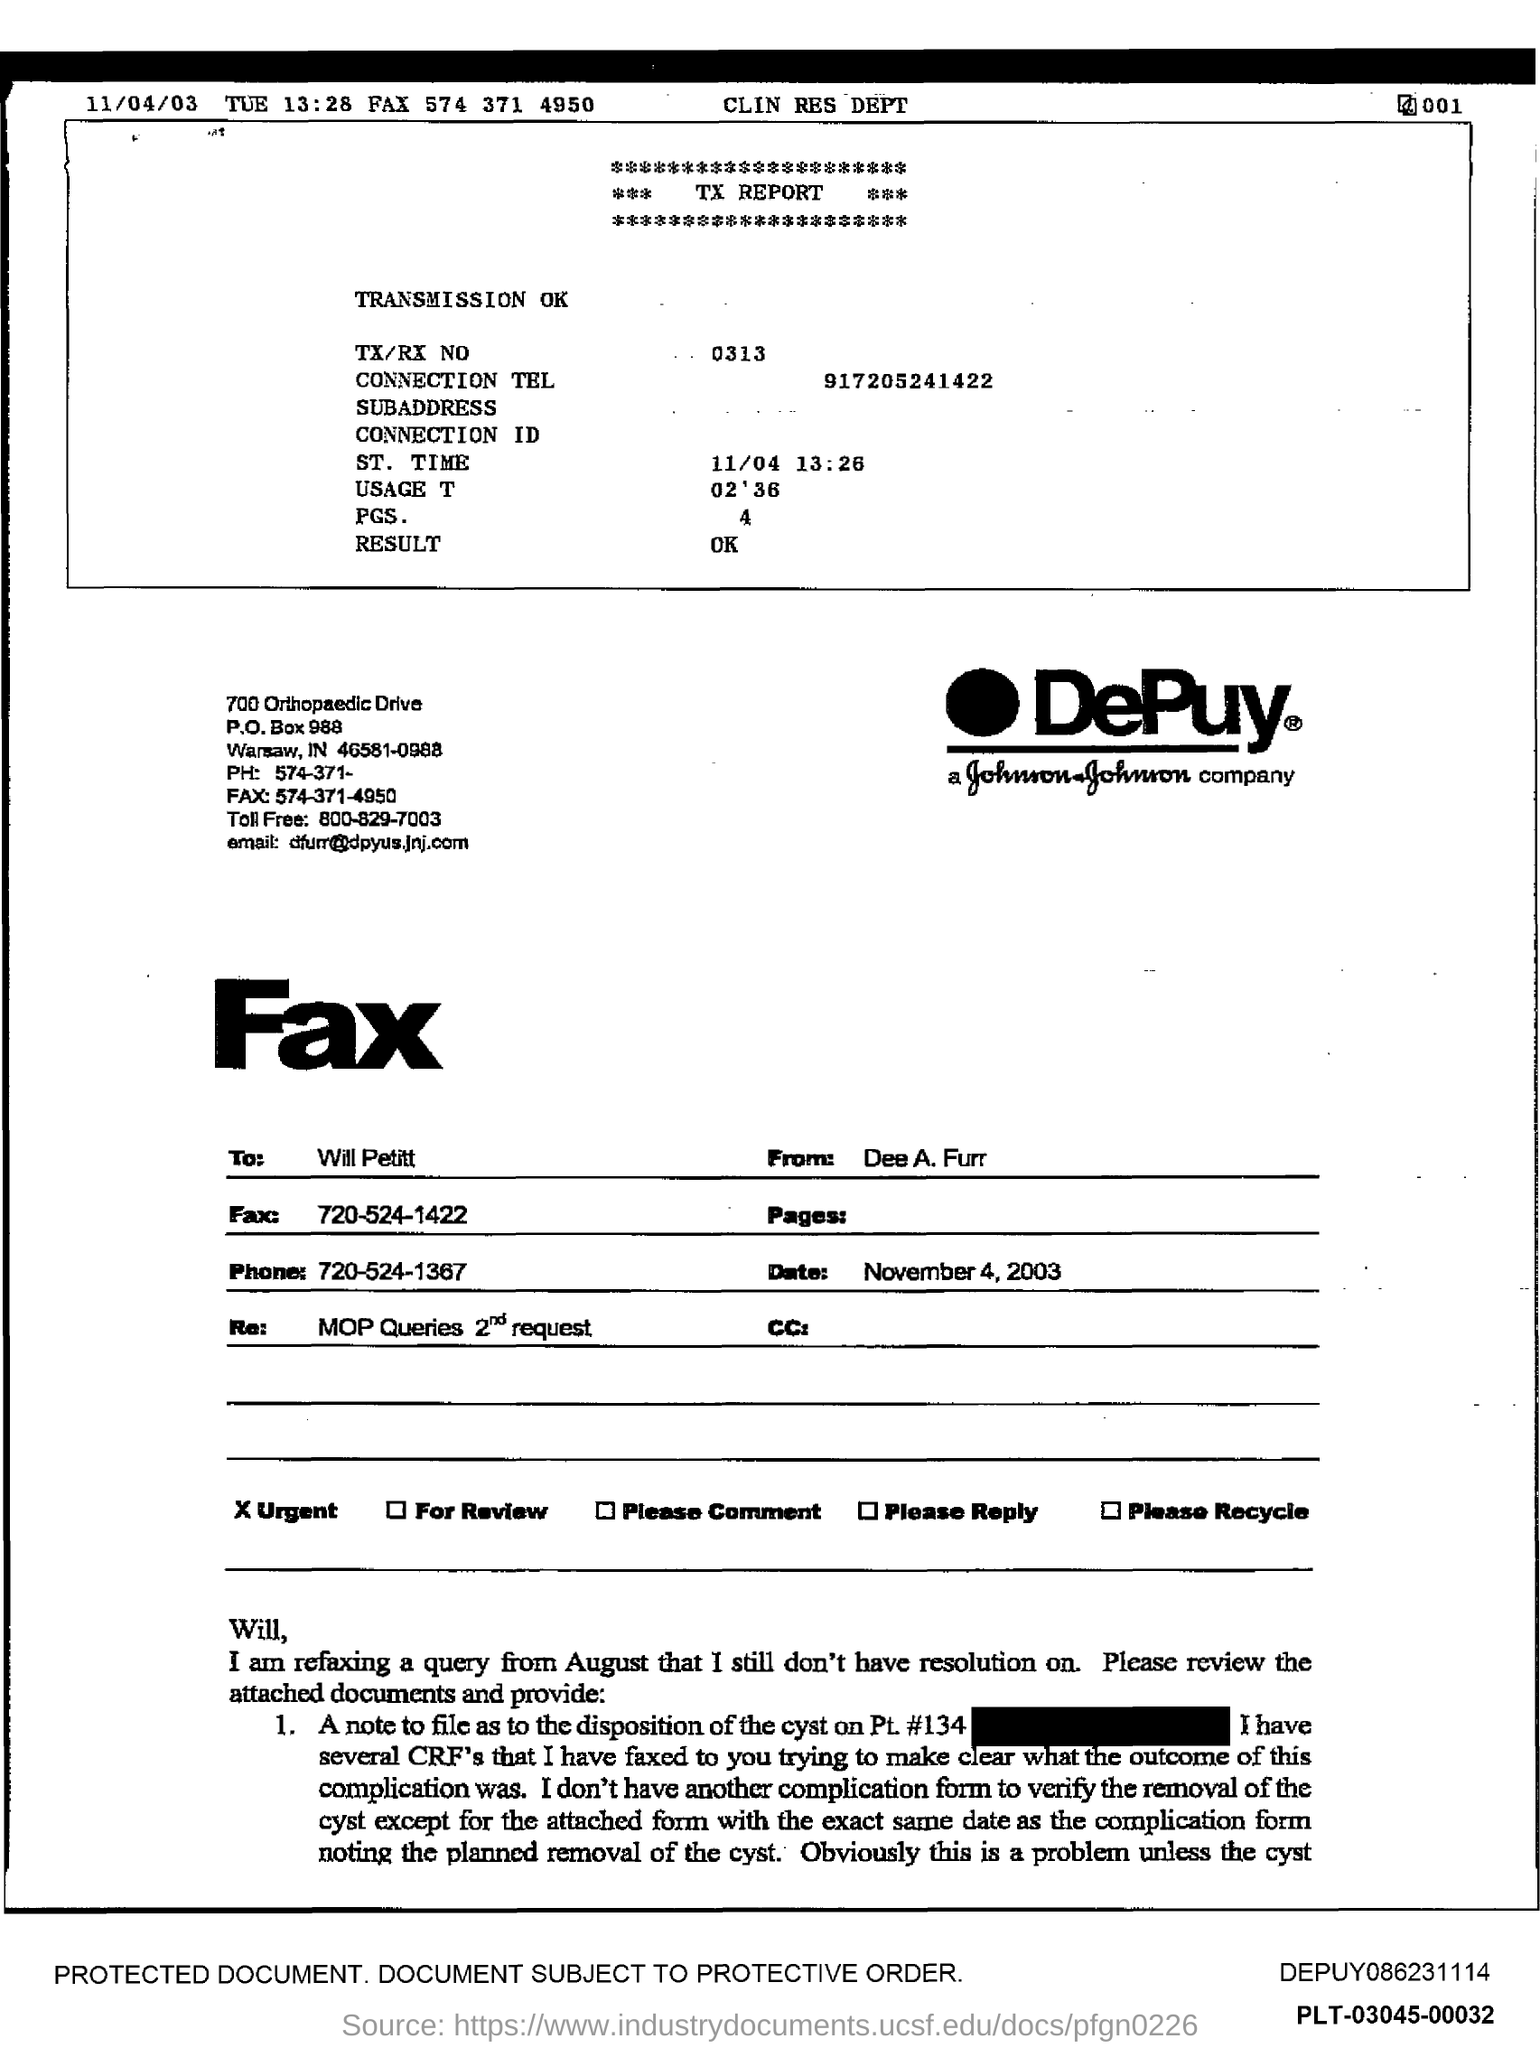List a handful of essential elements in this visual. The fax number given is 574 371 4950. The toll-free number provided is 800-829-7003. The date that is given on the left is 11/04/03. The date written on the form is November 4, 2003. The TX/RX number is 0313. 